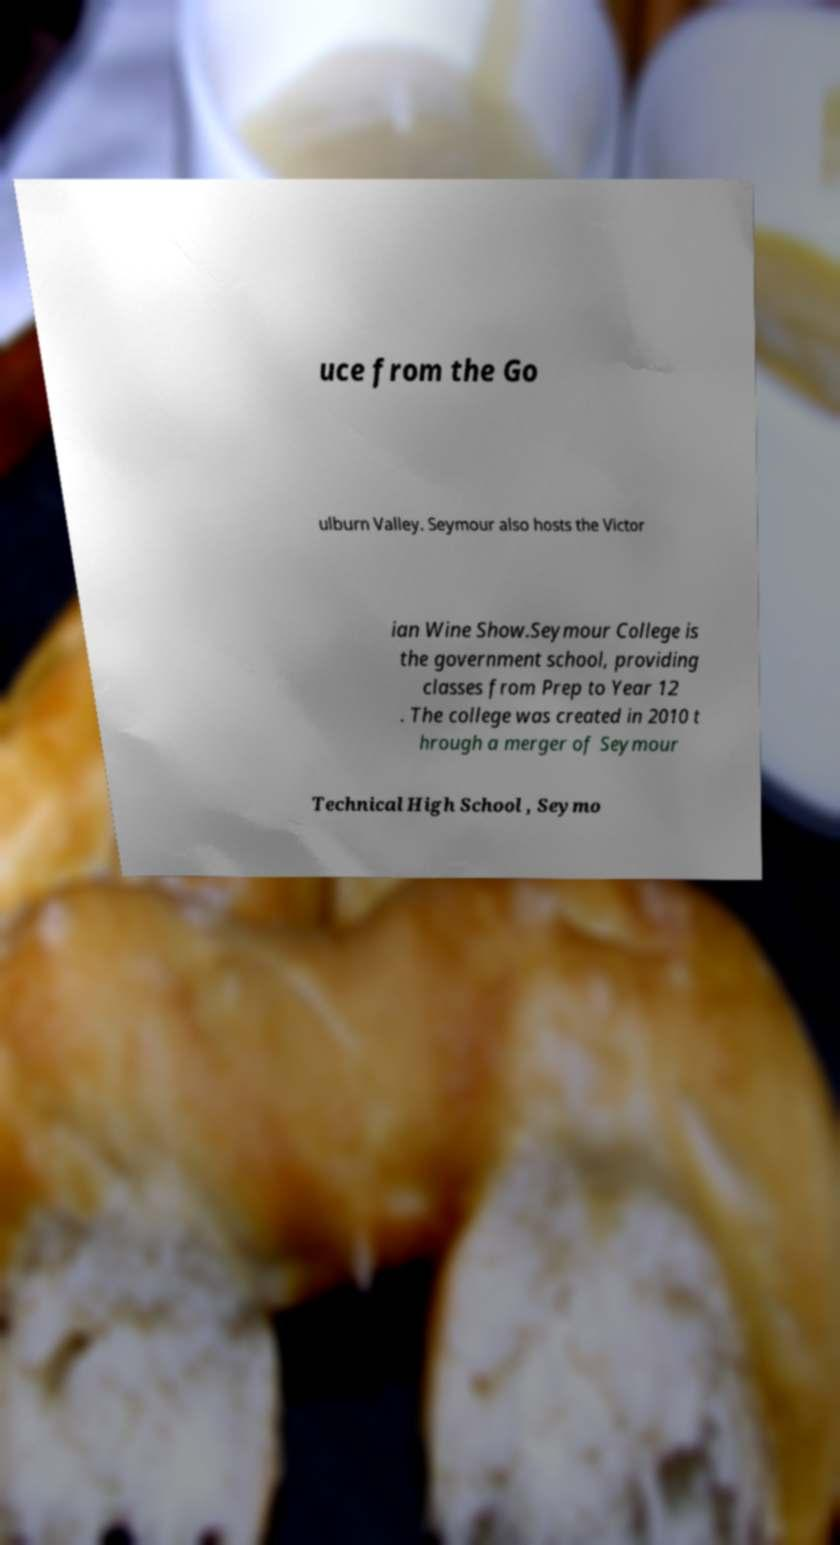I need the written content from this picture converted into text. Can you do that? uce from the Go ulburn Valley. Seymour also hosts the Victor ian Wine Show.Seymour College is the government school, providing classes from Prep to Year 12 . The college was created in 2010 t hrough a merger of Seymour Technical High School , Seymo 